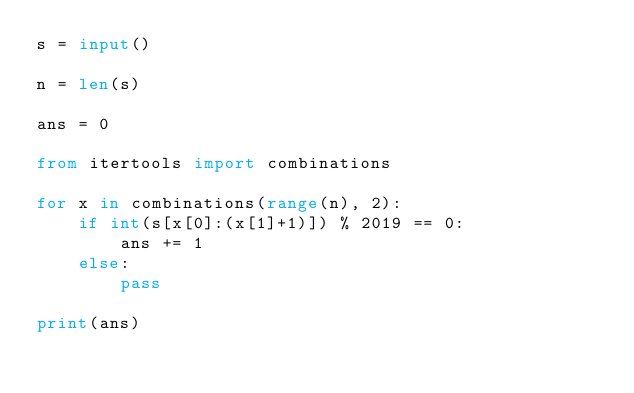Convert code to text. <code><loc_0><loc_0><loc_500><loc_500><_Python_>s = input()

n = len(s)

ans = 0

from itertools import combinations

for x in combinations(range(n), 2):
    if int(s[x[0]:(x[1]+1)]) % 2019 == 0:
        ans += 1
    else:
        pass

print(ans)
</code> 